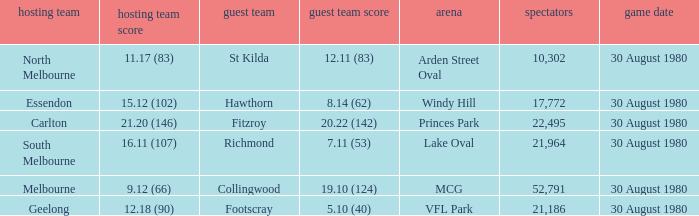Write the full table. {'header': ['hosting team', 'hosting team score', 'guest team', 'guest team score', 'arena', 'spectators', 'game date'], 'rows': [['North Melbourne', '11.17 (83)', 'St Kilda', '12.11 (83)', 'Arden Street Oval', '10,302', '30 August 1980'], ['Essendon', '15.12 (102)', 'Hawthorn', '8.14 (62)', 'Windy Hill', '17,772', '30 August 1980'], ['Carlton', '21.20 (146)', 'Fitzroy', '20.22 (142)', 'Princes Park', '22,495', '30 August 1980'], ['South Melbourne', '16.11 (107)', 'Richmond', '7.11 (53)', 'Lake Oval', '21,964', '30 August 1980'], ['Melbourne', '9.12 (66)', 'Collingwood', '19.10 (124)', 'MCG', '52,791', '30 August 1980'], ['Geelong', '12.18 (90)', 'Footscray', '5.10 (40)', 'VFL Park', '21,186', '30 August 1980']]} What is the home team score at lake oval? 16.11 (107). 